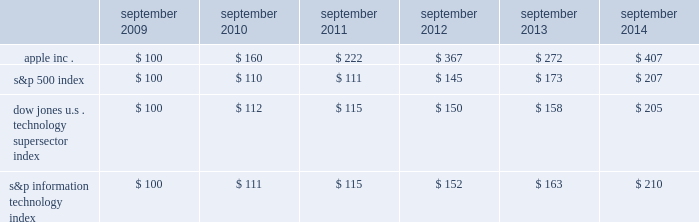Table of contents company stock performance the following graph shows a comparison of cumulative total shareholder return , calculated on a dividend reinvested basis , for the company , the s&p 500 index , the dow jones u.s .
Technology supersector index and the s&p information technology index for the five years ended september 27 , 2014 .
The company has added the s&p information technology index to the graph to capture the stock performance of companies whose products and services relate to those of the company .
The s&p information technology index replaces the s&p computer hardware index , which is no longer tracked by s&p .
The graph assumes $ 100 was invested in each of the company 2019s common stock , the s&p 500 index , the dow jones u.s .
Technology supersector index and the s&p information technology index as of the market close on september 25 , 2009 .
Note that historic stock price performance is not necessarily indicative of future stock price performance .
Copyright a9 2014 s&p , a division of the mcgraw-hill companies inc .
All rights reserved .
Copyright a9 2014 dow jones & co .
All rights reserved .
Apple inc .
| 2014 form 10-k | 23 * $ 100 invested on 9/25/09 in stock or index , including reinvestment of dividends .
Data points are the last day of each fiscal year for the company 2019s common stock and september 30th for indexes .
September september september september september september .

What was the percentage of cumulative total shareholder return for the five year period ended september 2014 for apple inc.? 
Computations: ((407 - 100) / 100)
Answer: 3.07. 